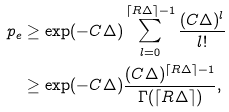Convert formula to latex. <formula><loc_0><loc_0><loc_500><loc_500>p _ { e } & \geq \exp ( - C \Delta ) \sum _ { l = 0 } ^ { \lceil R \Delta \rceil - 1 } \frac { ( C \Delta ) ^ { l } } { l ! } \\ & \geq \exp ( - C \Delta ) \frac { ( C \Delta ) ^ { \lceil R \Delta \rceil - 1 } } { \Gamma ( \lceil R \Delta \rceil ) } ,</formula> 